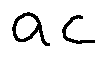Convert formula to latex. <formula><loc_0><loc_0><loc_500><loc_500>a c</formula> 